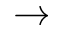<formula> <loc_0><loc_0><loc_500><loc_500>\rightarrow</formula> 